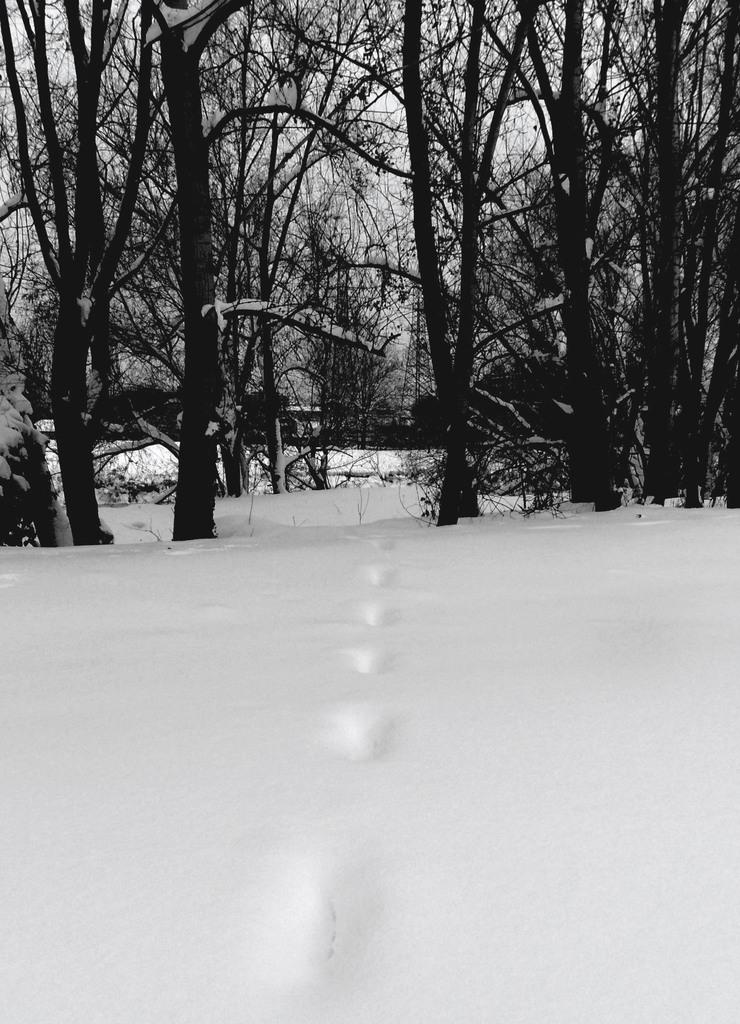What is covering the ground in the image? There is snow on the ground in the image. What type of vegetation can be seen in the image? There are trees in the image. What type of club is being used to punish the trees in the image? There is no club or punishment present in the image; it features snow on the ground and trees. 